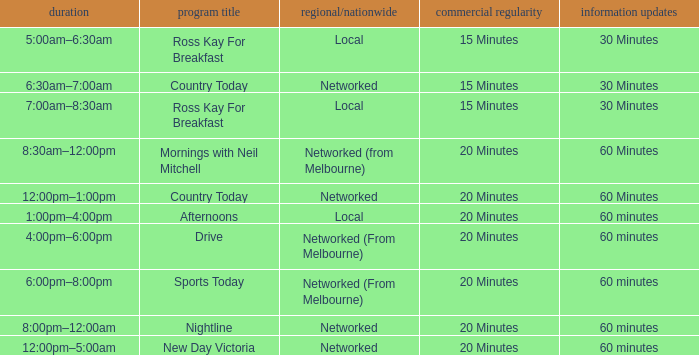What Local/Networked has a Show Name of nightline? Networked. 